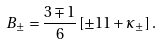<formula> <loc_0><loc_0><loc_500><loc_500>B _ { \pm } = \frac { 3 \mp 1 } { 6 } \left [ \pm 1 1 + \kappa _ { \pm } \right ] .</formula> 